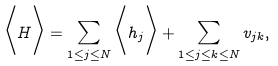<formula> <loc_0><loc_0><loc_500><loc_500>\Big < H \Big > = \sum _ { 1 \leq j \leq N } \Big < h _ { j } \Big > + \sum _ { 1 \leq j \leq k \leq N } v _ { j k } ,</formula> 